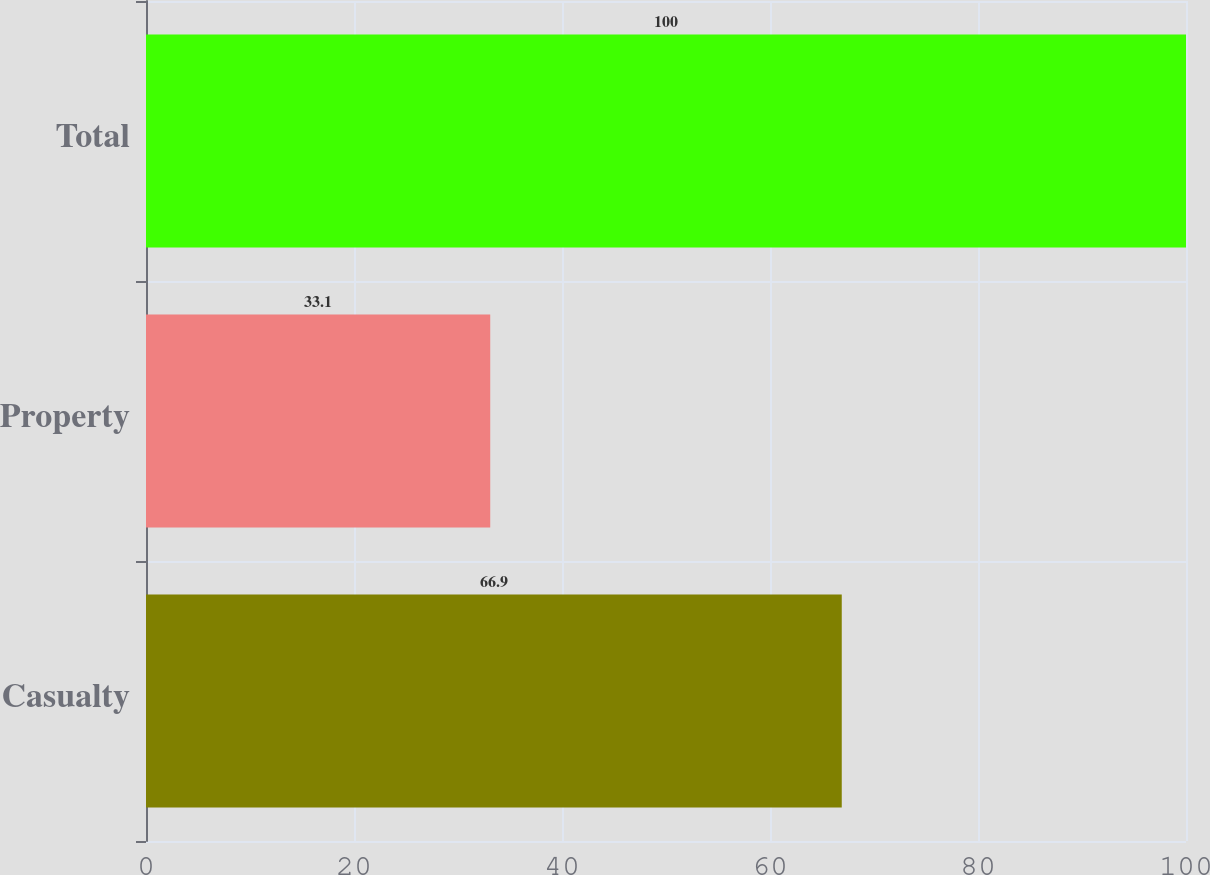<chart> <loc_0><loc_0><loc_500><loc_500><bar_chart><fcel>Casualty<fcel>Property<fcel>Total<nl><fcel>66.9<fcel>33.1<fcel>100<nl></chart> 